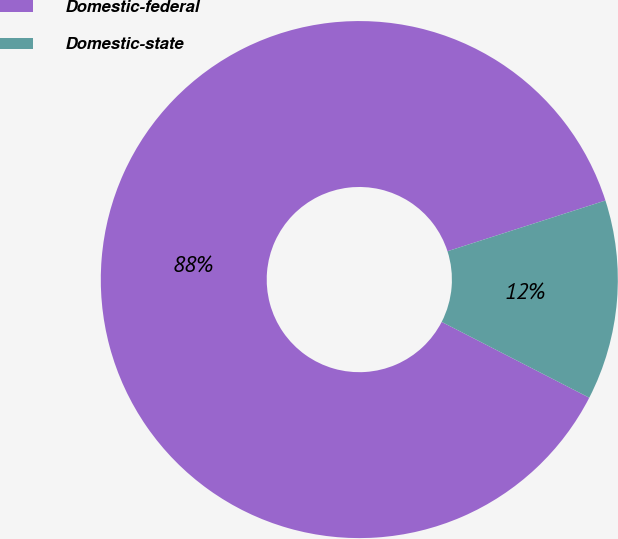<chart> <loc_0><loc_0><loc_500><loc_500><pie_chart><fcel>Domestic-federal<fcel>Domestic-state<nl><fcel>87.5%<fcel>12.5%<nl></chart> 